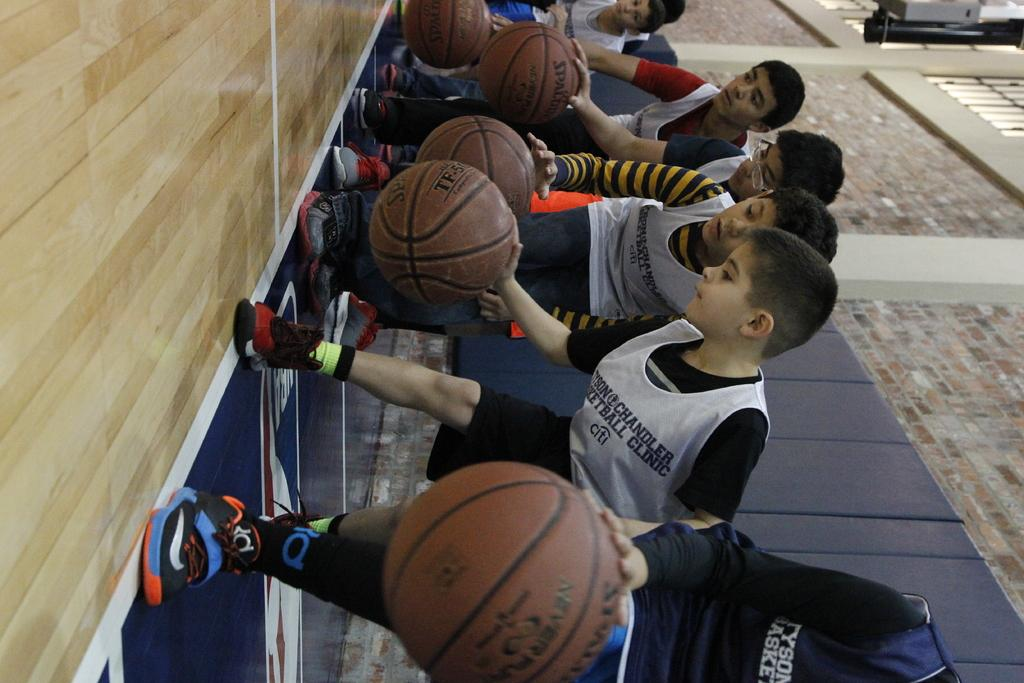What is happening in the foreground of the image? There are boys in the foreground of the image, and they are dribbling a ball on the floor. What can be seen in the background of the image? There is a wall in the background of the image. Are there any stones on the floor where the boys are playing? There is no mention of stones in the image; the boys are dribbling a ball on the floor. Can you see any spiders crawling on the wall in the background? There is no mention of spiders in the image; the wall in the background is not described in detail. 